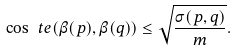Convert formula to latex. <formula><loc_0><loc_0><loc_500><loc_500>\cos \ t e ( \beta ( p ) , \beta ( q ) ) \leq \sqrt { \frac { \sigma ( p , q ) } { m } } .</formula> 